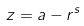Convert formula to latex. <formula><loc_0><loc_0><loc_500><loc_500>z = a - r ^ { s }</formula> 